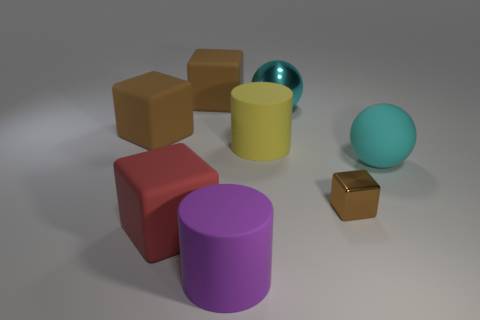There is a cyan thing that is in front of the matte cylinder that is to the right of the big cylinder in front of the tiny thing; what shape is it?
Offer a very short reply. Sphere. Is the number of matte cubes on the left side of the red matte block less than the number of large metallic spheres that are in front of the small object?
Your answer should be compact. No. Are there any rubber cubes of the same color as the rubber ball?
Keep it short and to the point. No. Is the purple thing made of the same material as the cyan sphere behind the cyan rubber ball?
Your answer should be very brief. No. Is there a big yellow rubber cylinder to the left of the big cyan object in front of the big yellow rubber cylinder?
Provide a succinct answer. Yes. What is the color of the block that is both in front of the yellow matte object and left of the large metal sphere?
Provide a succinct answer. Red. What size is the brown shiny cube?
Offer a terse response. Small. What number of rubber things are the same size as the red matte block?
Offer a very short reply. 5. Is the material of the brown thing that is to the right of the purple cylinder the same as the large cyan sphere that is in front of the metal ball?
Make the answer very short. No. The big block in front of the brown cube on the right side of the purple matte thing is made of what material?
Make the answer very short. Rubber. 